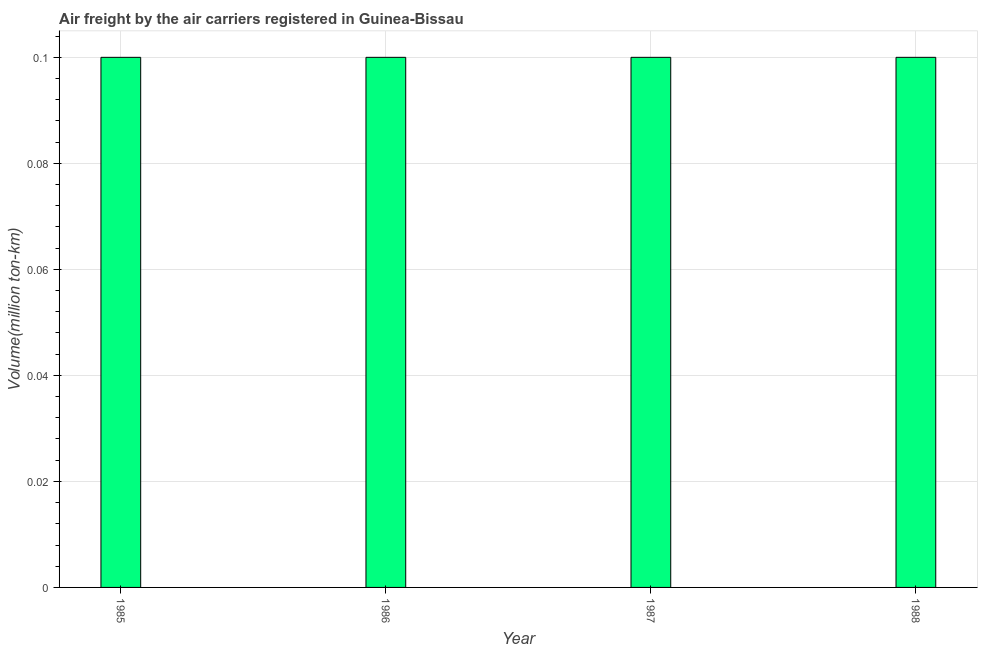Does the graph contain any zero values?
Provide a succinct answer. No. What is the title of the graph?
Provide a short and direct response. Air freight by the air carriers registered in Guinea-Bissau. What is the label or title of the X-axis?
Keep it short and to the point. Year. What is the label or title of the Y-axis?
Give a very brief answer. Volume(million ton-km). What is the air freight in 1985?
Your response must be concise. 0.1. Across all years, what is the maximum air freight?
Provide a succinct answer. 0.1. Across all years, what is the minimum air freight?
Provide a short and direct response. 0.1. What is the sum of the air freight?
Your answer should be very brief. 0.4. What is the difference between the air freight in 1987 and 1988?
Offer a terse response. 0. What is the average air freight per year?
Provide a succinct answer. 0.1. What is the median air freight?
Give a very brief answer. 0.1. In how many years, is the air freight greater than 0.012 million ton-km?
Ensure brevity in your answer.  4. Do a majority of the years between 1987 and 1988 (inclusive) have air freight greater than 0.048 million ton-km?
Give a very brief answer. Yes. What is the ratio of the air freight in 1985 to that in 1986?
Make the answer very short. 1. Is the air freight in 1985 less than that in 1987?
Keep it short and to the point. No. Is the difference between the air freight in 1987 and 1988 greater than the difference between any two years?
Offer a terse response. Yes. In how many years, is the air freight greater than the average air freight taken over all years?
Give a very brief answer. 0. How many bars are there?
Provide a succinct answer. 4. What is the difference between two consecutive major ticks on the Y-axis?
Give a very brief answer. 0.02. What is the Volume(million ton-km) in 1985?
Your response must be concise. 0.1. What is the Volume(million ton-km) of 1986?
Your answer should be very brief. 0.1. What is the Volume(million ton-km) of 1987?
Your answer should be very brief. 0.1. What is the Volume(million ton-km) of 1988?
Your response must be concise. 0.1. What is the difference between the Volume(million ton-km) in 1985 and 1988?
Your answer should be compact. 0. What is the difference between the Volume(million ton-km) in 1986 and 1987?
Provide a short and direct response. 0. What is the difference between the Volume(million ton-km) in 1986 and 1988?
Make the answer very short. 0. What is the ratio of the Volume(million ton-km) in 1986 to that in 1988?
Keep it short and to the point. 1. What is the ratio of the Volume(million ton-km) in 1987 to that in 1988?
Keep it short and to the point. 1. 